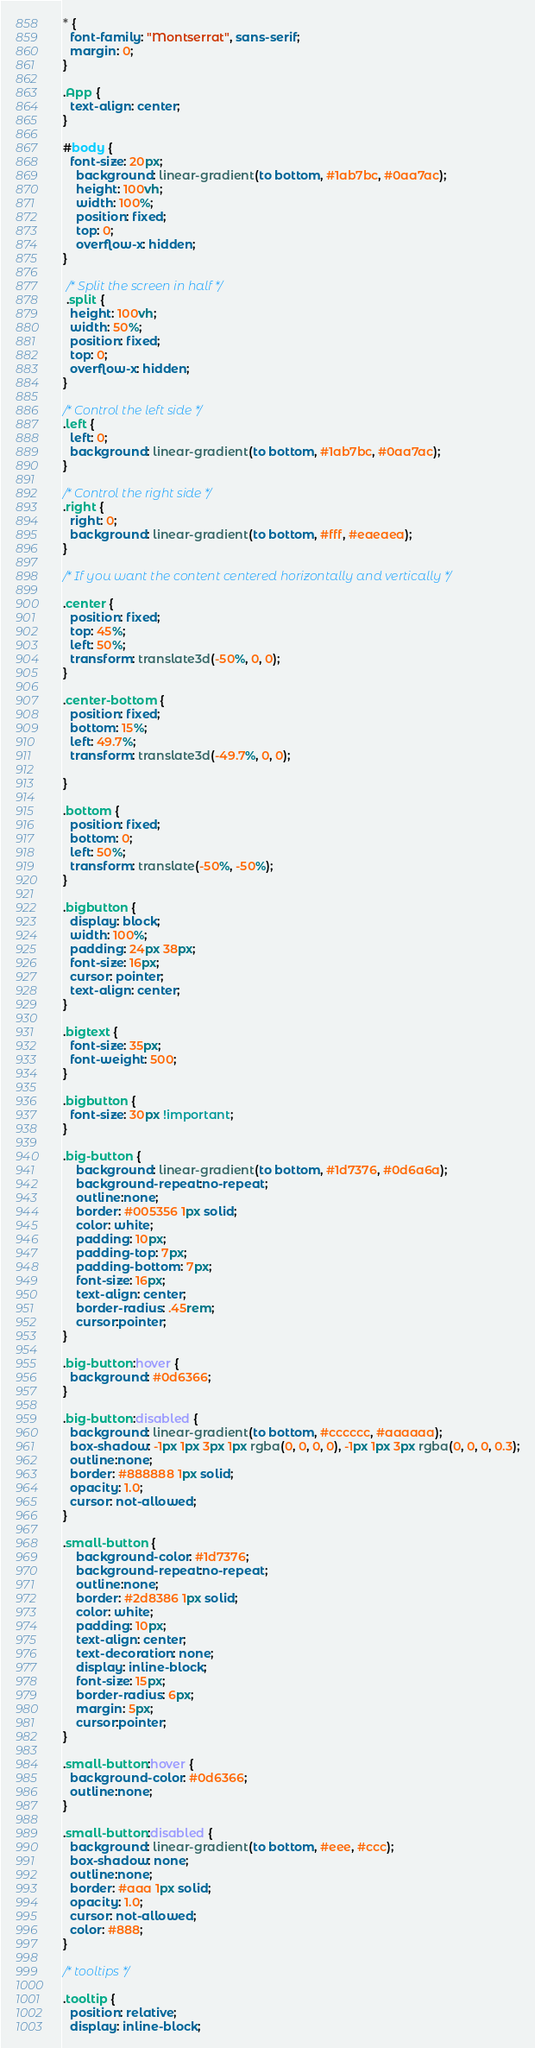Convert code to text. <code><loc_0><loc_0><loc_500><loc_500><_CSS_>* {
  font-family: "Montserrat", sans-serif;
  margin: 0;
}

.App {
  text-align: center;
}

#body {
  font-size: 20px;
    background: linear-gradient(to bottom, #1ab7bc, #0aa7ac);
    height: 100vh;
    width: 100%;
    position: fixed;
    top: 0;
    overflow-x: hidden;
}

 /* Split the screen in half */
 .split {
  height: 100vh;
  width: 50%;
  position: fixed;
  top: 0;
  overflow-x: hidden;
}

/* Control the left side */
.left {
  left: 0;
  background: linear-gradient(to bottom, #1ab7bc, #0aa7ac);
}

/* Control the right side */
.right {
  right: 0;
  background: linear-gradient(to bottom, #fff, #eaeaea);
}

/* If you want the content centered horizontally and vertically */

.center {
  position: fixed;
  top: 45%;
  left: 50%;
  transform: translate3d(-50%, 0, 0);
}

.center-bottom {
  position: fixed;
  bottom: 15%;
  left: 49.7%;
  transform: translate3d(-49.7%, 0, 0);

}

.bottom {
  position: fixed;
  bottom: 0;
  left: 50%;
  transform: translate(-50%, -50%);
}

.bigbutton {
  display: block;
  width: 100%;
  padding: 24px 38px;
  font-size: 16px;
  cursor: pointer;
  text-align: center;
}

.bigtext {
  font-size: 35px;
  font-weight: 500;
}

.bigbutton {
  font-size: 30px !important;
}

.big-button {
    background: linear-gradient(to bottom, #1d7376, #0d6a6a);
    background-repeat:no-repeat;
    outline:none;
    border: #005356 1px solid;
    color: white;
    padding: 10px;
    padding-top: 7px;
    padding-bottom: 7px;
    font-size: 16px;
    text-align: center;
    border-radius: .45rem;
    cursor:pointer;
}

.big-button:hover {
  background: #0d6366;
}

.big-button:disabled {
  background: linear-gradient(to bottom, #cccccc, #aaaaaa);
  box-shadow: -1px 1px 3px 1px rgba(0, 0, 0, 0), -1px 1px 3px rgba(0, 0, 0, 0.3);
  outline:none;
  border: #888888 1px solid;
  opacity: 1.0; 
  cursor: not-allowed;
}

.small-button {
    background-color: #1d7376;
    background-repeat:no-repeat;
    outline:none;
    border: #2d8386 1px solid;
    color: white;
    padding: 10px;
    text-align: center;
    text-decoration: none;
    display: inline-block;
    font-size: 15px;
    border-radius: 6px;
    margin: 5px;
    cursor:pointer;
}

.small-button:hover {
  background-color: #0d6366;
  outline:none;
}

.small-button:disabled {
  background: linear-gradient(to bottom, #eee, #ccc);
  box-shadow: none;
  outline:none;
  border: #aaa 1px solid;
  opacity: 1.0; 
  cursor: not-allowed;
  color: #888;
}

/* tooltips */

.tooltip {
  position: relative;
  display: inline-block;</code> 